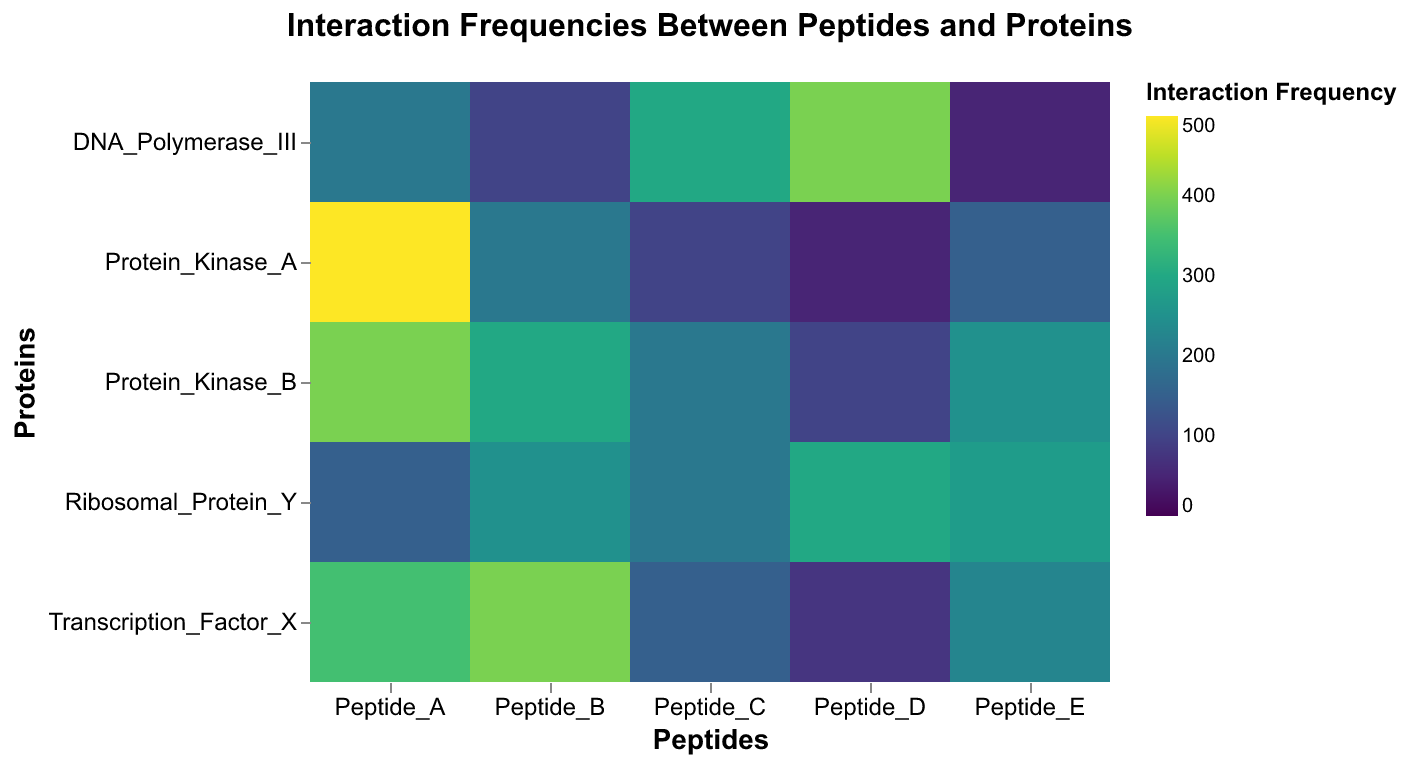How many different peptides are shown in the heatmap? The heatmap has an x-axis labeled "Peptides" with five distinct labels, indicating the different peptides.
Answer: 5 Which peptide shows the highest interaction frequency with Protein_Kinase_A? The color scale in the heatmap shows a range of interaction frequencies, and the corresponding cell for Peptide_A with Protein_Kinase_A shows the highest frequency because it is the darkest in color.
Answer: Peptide_A What is the interaction frequency between Transcription_Factor_X and Peptide_B? Locate the cell at the intersection of Transcription_Factor_X and Peptide_B. The color of this cell and the legend indicate the interaction frequency.
Answer: 400 Which protein has the highest interaction frequency with Peptide_E? By inspecting the cells in the Peptide_E column, the darkest cell corresponds to the highest interaction frequency, which is associated with Protein_Kinase_B.
Answer: Protein_Kinase_B What's the average interaction frequency of Protein_Kinase_B with all peptides? Sum the interaction frequencies of Protein_Kinase_B across all peptides (400 + 300 + 200 + 100 + 250) and divide by the number of peptides (5): (400 + 300 + 200 + 100 + 250) / 5 = 1250 / 5 = 250
Answer: 250 Compare the interaction frequencies of Peptide_C with Protein_Kinase_A and DNA_Polymerase_III. Which one is higher? Locate the cells Peptide_C with Protein_Kinase_A and Peptide_C with DNA_Polymerase_III. Compare their colors; the cell DNA_Polymerase_III and Peptide_C is darker, indicating a higher frequency.
Answer: DNA_Polymerase_III Which peptide overall has the lowest mean interaction frequency with all proteins? Calculate the mean interaction frequencies of each peptide with all proteins (Peptide_A: (500+400+350+200+150)/5; Peptide_B: (200+300+400+100+250)/5; Peptide_C: (100+200+150+300+200)/5; Peptide_D: (50+100+75+400+300)/5; Peptide_E: (150+250+225+50+275)/5) and identify the minimum.
Answer: Peptide_D How does the interaction frequency of Peptide_A differ between Protein_Kinase_A and Ribosomal_Protein_Y? Subtract the interaction frequency of Peptide_A with Ribosomal_Protein_Y from that with Protein_Kinase_A: 500 - 150 = 350
Answer: 350 Which protein has the most interaction with Peptide_C in comparison to the other peptides? The protein with the darkest cell in the Peptide_C column (DNA_Polymerase_III has the darkest color for Peptide_C, indicating the highest frequency) needs to be found.
Answer: DNA_Polymerase_III 